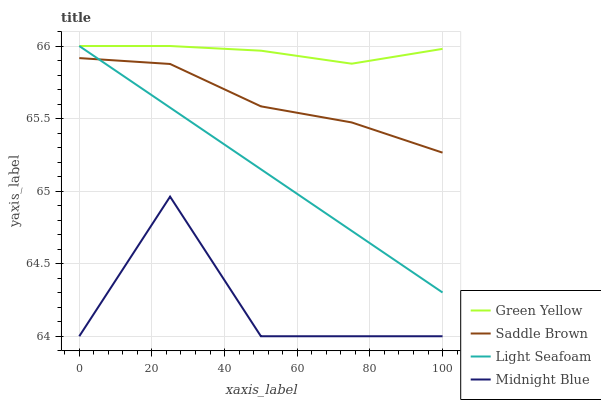Does Midnight Blue have the minimum area under the curve?
Answer yes or no. Yes. Does Green Yellow have the maximum area under the curve?
Answer yes or no. Yes. Does Saddle Brown have the minimum area under the curve?
Answer yes or no. No. Does Saddle Brown have the maximum area under the curve?
Answer yes or no. No. Is Light Seafoam the smoothest?
Answer yes or no. Yes. Is Midnight Blue the roughest?
Answer yes or no. Yes. Is Saddle Brown the smoothest?
Answer yes or no. No. Is Saddle Brown the roughest?
Answer yes or no. No. Does Midnight Blue have the lowest value?
Answer yes or no. Yes. Does Saddle Brown have the lowest value?
Answer yes or no. No. Does Light Seafoam have the highest value?
Answer yes or no. Yes. Does Saddle Brown have the highest value?
Answer yes or no. No. Is Midnight Blue less than Saddle Brown?
Answer yes or no. Yes. Is Saddle Brown greater than Midnight Blue?
Answer yes or no. Yes. Does Light Seafoam intersect Saddle Brown?
Answer yes or no. Yes. Is Light Seafoam less than Saddle Brown?
Answer yes or no. No. Is Light Seafoam greater than Saddle Brown?
Answer yes or no. No. Does Midnight Blue intersect Saddle Brown?
Answer yes or no. No. 